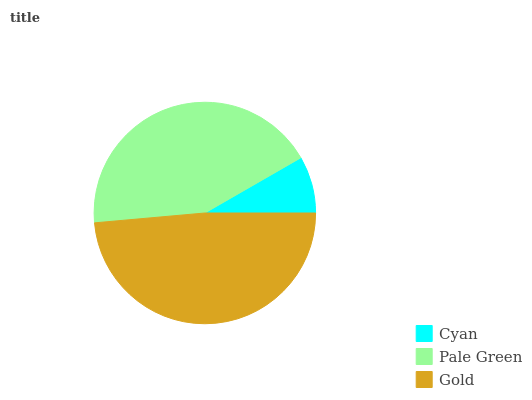Is Cyan the minimum?
Answer yes or no. Yes. Is Gold the maximum?
Answer yes or no. Yes. Is Pale Green the minimum?
Answer yes or no. No. Is Pale Green the maximum?
Answer yes or no. No. Is Pale Green greater than Cyan?
Answer yes or no. Yes. Is Cyan less than Pale Green?
Answer yes or no. Yes. Is Cyan greater than Pale Green?
Answer yes or no. No. Is Pale Green less than Cyan?
Answer yes or no. No. Is Pale Green the high median?
Answer yes or no. Yes. Is Pale Green the low median?
Answer yes or no. Yes. Is Cyan the high median?
Answer yes or no. No. Is Gold the low median?
Answer yes or no. No. 